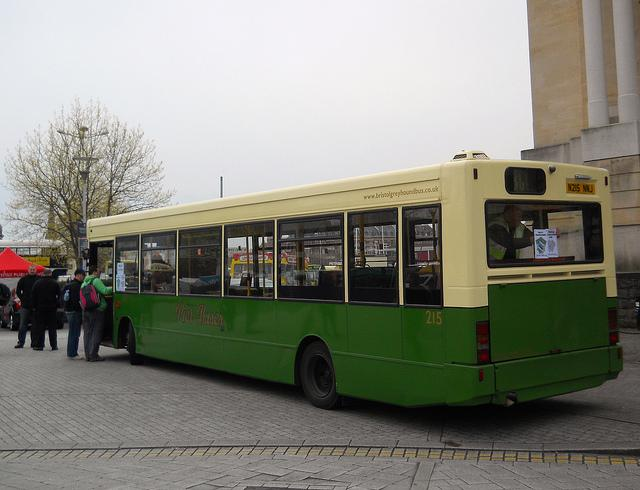In which country is this bus taking on passengers? Please explain your reasoning. england. A green and tan public bus is in the street. 